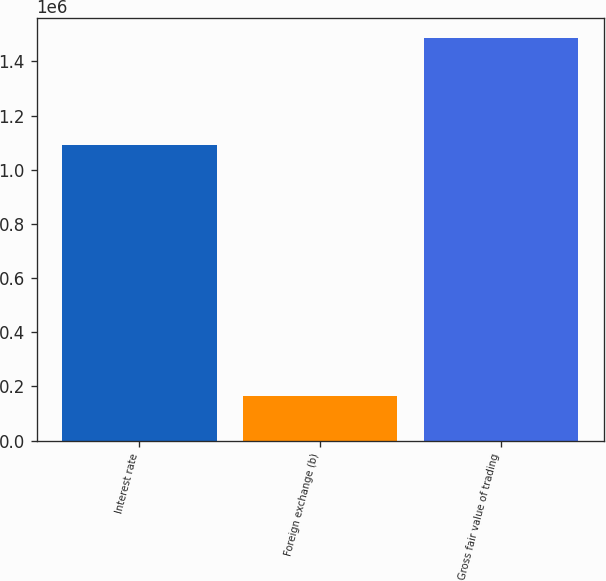Convert chart to OTSL. <chart><loc_0><loc_0><loc_500><loc_500><bar_chart><fcel>Interest rate<fcel>Foreign exchange (b)<fcel>Gross fair value of trading<nl><fcel>1.09044e+06<fcel>164730<fcel>1.48511e+06<nl></chart> 